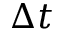<formula> <loc_0><loc_0><loc_500><loc_500>\Delta t</formula> 